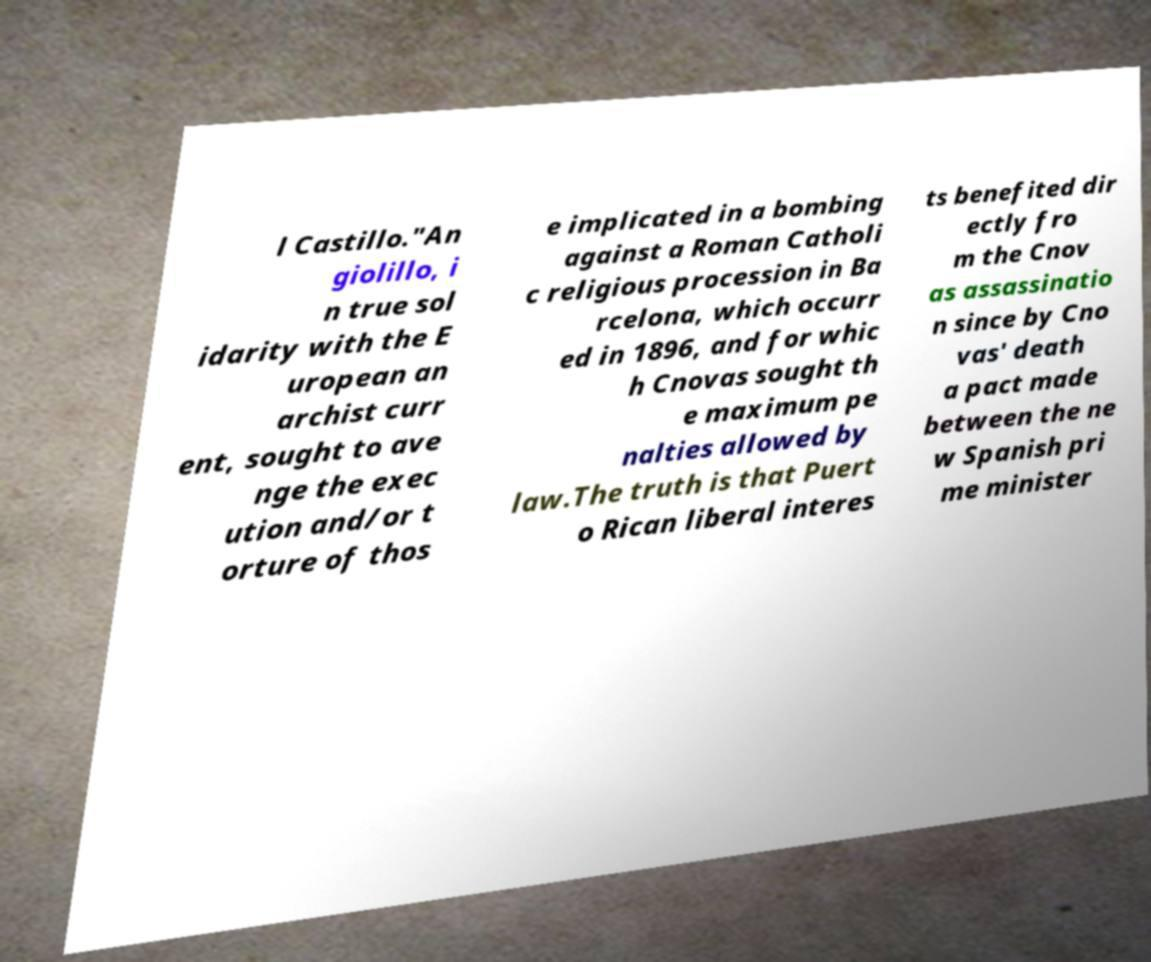Can you accurately transcribe the text from the provided image for me? l Castillo."An giolillo, i n true sol idarity with the E uropean an archist curr ent, sought to ave nge the exec ution and/or t orture of thos e implicated in a bombing against a Roman Catholi c religious procession in Ba rcelona, which occurr ed in 1896, and for whic h Cnovas sought th e maximum pe nalties allowed by law.The truth is that Puert o Rican liberal interes ts benefited dir ectly fro m the Cnov as assassinatio n since by Cno vas' death a pact made between the ne w Spanish pri me minister 